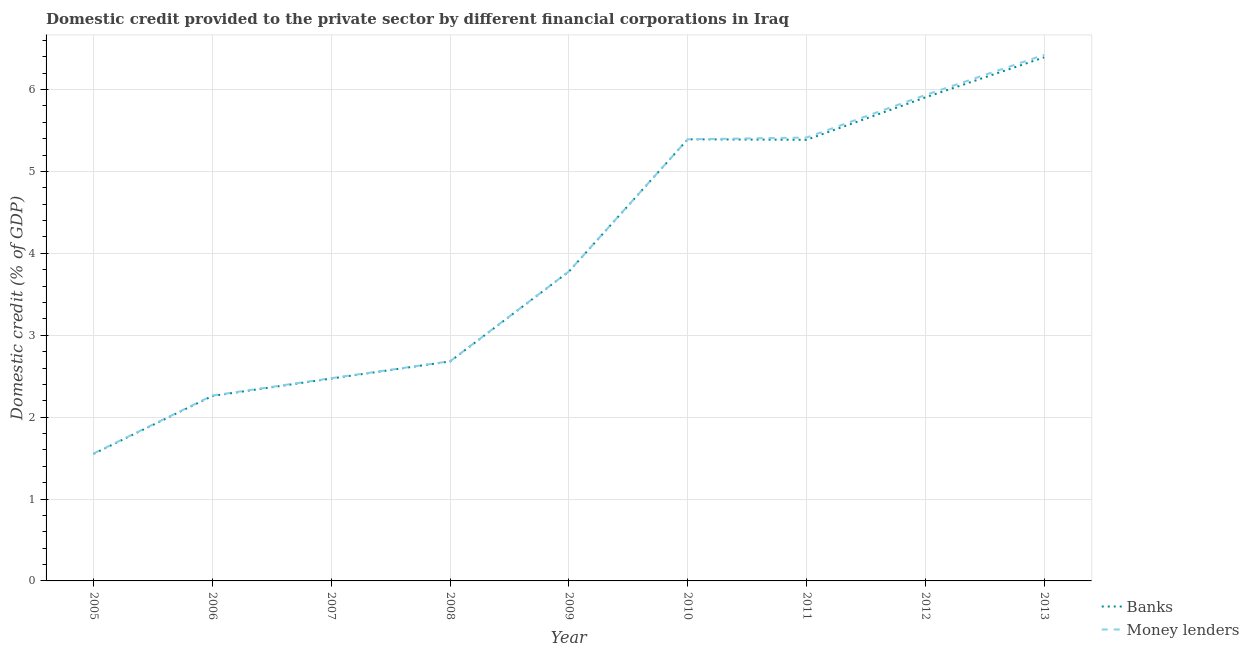Is the number of lines equal to the number of legend labels?
Ensure brevity in your answer.  Yes. What is the domestic credit provided by banks in 2012?
Offer a very short reply. 5.9. Across all years, what is the maximum domestic credit provided by banks?
Provide a short and direct response. 6.39. Across all years, what is the minimum domestic credit provided by money lenders?
Your response must be concise. 1.56. In which year was the domestic credit provided by money lenders minimum?
Ensure brevity in your answer.  2005. What is the total domestic credit provided by money lenders in the graph?
Provide a succinct answer. 35.92. What is the difference between the domestic credit provided by banks in 2006 and that in 2008?
Your answer should be very brief. -0.42. What is the difference between the domestic credit provided by money lenders in 2012 and the domestic credit provided by banks in 2013?
Keep it short and to the point. -0.46. What is the average domestic credit provided by banks per year?
Give a very brief answer. 3.98. In the year 2008, what is the difference between the domestic credit provided by money lenders and domestic credit provided by banks?
Give a very brief answer. 0. In how many years, is the domestic credit provided by banks greater than 5.8 %?
Offer a very short reply. 2. What is the ratio of the domestic credit provided by banks in 2005 to that in 2010?
Offer a terse response. 0.29. Is the difference between the domestic credit provided by money lenders in 2009 and 2010 greater than the difference between the domestic credit provided by banks in 2009 and 2010?
Offer a terse response. Yes. What is the difference between the highest and the second highest domestic credit provided by money lenders?
Your answer should be very brief. 0.49. What is the difference between the highest and the lowest domestic credit provided by banks?
Give a very brief answer. 4.84. Is the domestic credit provided by money lenders strictly less than the domestic credit provided by banks over the years?
Give a very brief answer. No. How many lines are there?
Offer a terse response. 2. How many years are there in the graph?
Your answer should be compact. 9. Are the values on the major ticks of Y-axis written in scientific E-notation?
Give a very brief answer. No. Does the graph contain any zero values?
Your response must be concise. No. Where does the legend appear in the graph?
Your answer should be very brief. Bottom right. How are the legend labels stacked?
Provide a short and direct response. Vertical. What is the title of the graph?
Provide a succinct answer. Domestic credit provided to the private sector by different financial corporations in Iraq. Does "Start a business" appear as one of the legend labels in the graph?
Provide a short and direct response. No. What is the label or title of the Y-axis?
Give a very brief answer. Domestic credit (% of GDP). What is the Domestic credit (% of GDP) of Banks in 2005?
Provide a short and direct response. 1.55. What is the Domestic credit (% of GDP) in Money lenders in 2005?
Give a very brief answer. 1.56. What is the Domestic credit (% of GDP) of Banks in 2006?
Offer a very short reply. 2.26. What is the Domestic credit (% of GDP) of Money lenders in 2006?
Provide a short and direct response. 2.26. What is the Domestic credit (% of GDP) in Banks in 2007?
Your response must be concise. 2.47. What is the Domestic credit (% of GDP) in Money lenders in 2007?
Your answer should be very brief. 2.48. What is the Domestic credit (% of GDP) in Banks in 2008?
Your response must be concise. 2.68. What is the Domestic credit (% of GDP) in Money lenders in 2008?
Provide a short and direct response. 2.68. What is the Domestic credit (% of GDP) in Banks in 2009?
Your answer should be compact. 3.78. What is the Domestic credit (% of GDP) of Money lenders in 2009?
Your answer should be compact. 3.78. What is the Domestic credit (% of GDP) in Banks in 2010?
Keep it short and to the point. 5.39. What is the Domestic credit (% of GDP) in Money lenders in 2010?
Give a very brief answer. 5.39. What is the Domestic credit (% of GDP) in Banks in 2011?
Your answer should be compact. 5.39. What is the Domestic credit (% of GDP) in Money lenders in 2011?
Ensure brevity in your answer.  5.41. What is the Domestic credit (% of GDP) in Banks in 2012?
Give a very brief answer. 5.9. What is the Domestic credit (% of GDP) of Money lenders in 2012?
Offer a very short reply. 5.93. What is the Domestic credit (% of GDP) of Banks in 2013?
Make the answer very short. 6.39. What is the Domestic credit (% of GDP) in Money lenders in 2013?
Your answer should be very brief. 6.42. Across all years, what is the maximum Domestic credit (% of GDP) of Banks?
Provide a succinct answer. 6.39. Across all years, what is the maximum Domestic credit (% of GDP) in Money lenders?
Give a very brief answer. 6.42. Across all years, what is the minimum Domestic credit (% of GDP) in Banks?
Provide a succinct answer. 1.55. Across all years, what is the minimum Domestic credit (% of GDP) of Money lenders?
Keep it short and to the point. 1.56. What is the total Domestic credit (% of GDP) in Banks in the graph?
Make the answer very short. 35.82. What is the total Domestic credit (% of GDP) of Money lenders in the graph?
Make the answer very short. 35.92. What is the difference between the Domestic credit (% of GDP) of Banks in 2005 and that in 2006?
Offer a very short reply. -0.71. What is the difference between the Domestic credit (% of GDP) of Money lenders in 2005 and that in 2006?
Give a very brief answer. -0.71. What is the difference between the Domestic credit (% of GDP) in Banks in 2005 and that in 2007?
Offer a terse response. -0.92. What is the difference between the Domestic credit (% of GDP) in Money lenders in 2005 and that in 2007?
Your answer should be very brief. -0.92. What is the difference between the Domestic credit (% of GDP) of Banks in 2005 and that in 2008?
Ensure brevity in your answer.  -1.13. What is the difference between the Domestic credit (% of GDP) of Money lenders in 2005 and that in 2008?
Your response must be concise. -1.13. What is the difference between the Domestic credit (% of GDP) in Banks in 2005 and that in 2009?
Offer a very short reply. -2.23. What is the difference between the Domestic credit (% of GDP) of Money lenders in 2005 and that in 2009?
Keep it short and to the point. -2.22. What is the difference between the Domestic credit (% of GDP) of Banks in 2005 and that in 2010?
Make the answer very short. -3.84. What is the difference between the Domestic credit (% of GDP) of Money lenders in 2005 and that in 2010?
Keep it short and to the point. -3.84. What is the difference between the Domestic credit (% of GDP) of Banks in 2005 and that in 2011?
Give a very brief answer. -3.84. What is the difference between the Domestic credit (% of GDP) of Money lenders in 2005 and that in 2011?
Your answer should be compact. -3.86. What is the difference between the Domestic credit (% of GDP) of Banks in 2005 and that in 2012?
Make the answer very short. -4.35. What is the difference between the Domestic credit (% of GDP) of Money lenders in 2005 and that in 2012?
Keep it short and to the point. -4.38. What is the difference between the Domestic credit (% of GDP) in Banks in 2005 and that in 2013?
Your answer should be very brief. -4.84. What is the difference between the Domestic credit (% of GDP) of Money lenders in 2005 and that in 2013?
Provide a succinct answer. -4.87. What is the difference between the Domestic credit (% of GDP) of Banks in 2006 and that in 2007?
Your response must be concise. -0.21. What is the difference between the Domestic credit (% of GDP) in Money lenders in 2006 and that in 2007?
Your answer should be compact. -0.21. What is the difference between the Domestic credit (% of GDP) of Banks in 2006 and that in 2008?
Offer a terse response. -0.42. What is the difference between the Domestic credit (% of GDP) of Money lenders in 2006 and that in 2008?
Give a very brief answer. -0.42. What is the difference between the Domestic credit (% of GDP) of Banks in 2006 and that in 2009?
Give a very brief answer. -1.52. What is the difference between the Domestic credit (% of GDP) in Money lenders in 2006 and that in 2009?
Provide a succinct answer. -1.51. What is the difference between the Domestic credit (% of GDP) of Banks in 2006 and that in 2010?
Your answer should be very brief. -3.13. What is the difference between the Domestic credit (% of GDP) of Money lenders in 2006 and that in 2010?
Ensure brevity in your answer.  -3.13. What is the difference between the Domestic credit (% of GDP) in Banks in 2006 and that in 2011?
Offer a very short reply. -3.13. What is the difference between the Domestic credit (% of GDP) of Money lenders in 2006 and that in 2011?
Offer a very short reply. -3.15. What is the difference between the Domestic credit (% of GDP) of Banks in 2006 and that in 2012?
Provide a succinct answer. -3.65. What is the difference between the Domestic credit (% of GDP) of Money lenders in 2006 and that in 2012?
Give a very brief answer. -3.67. What is the difference between the Domestic credit (% of GDP) of Banks in 2006 and that in 2013?
Give a very brief answer. -4.13. What is the difference between the Domestic credit (% of GDP) in Money lenders in 2006 and that in 2013?
Offer a very short reply. -4.16. What is the difference between the Domestic credit (% of GDP) in Banks in 2007 and that in 2008?
Your answer should be very brief. -0.21. What is the difference between the Domestic credit (% of GDP) of Money lenders in 2007 and that in 2008?
Keep it short and to the point. -0.21. What is the difference between the Domestic credit (% of GDP) in Banks in 2007 and that in 2009?
Give a very brief answer. -1.31. What is the difference between the Domestic credit (% of GDP) in Money lenders in 2007 and that in 2009?
Keep it short and to the point. -1.3. What is the difference between the Domestic credit (% of GDP) in Banks in 2007 and that in 2010?
Offer a very short reply. -2.92. What is the difference between the Domestic credit (% of GDP) in Money lenders in 2007 and that in 2010?
Your answer should be very brief. -2.92. What is the difference between the Domestic credit (% of GDP) in Banks in 2007 and that in 2011?
Give a very brief answer. -2.92. What is the difference between the Domestic credit (% of GDP) of Money lenders in 2007 and that in 2011?
Ensure brevity in your answer.  -2.94. What is the difference between the Domestic credit (% of GDP) of Banks in 2007 and that in 2012?
Offer a terse response. -3.43. What is the difference between the Domestic credit (% of GDP) of Money lenders in 2007 and that in 2012?
Your response must be concise. -3.46. What is the difference between the Domestic credit (% of GDP) of Banks in 2007 and that in 2013?
Provide a short and direct response. -3.92. What is the difference between the Domestic credit (% of GDP) of Money lenders in 2007 and that in 2013?
Keep it short and to the point. -3.95. What is the difference between the Domestic credit (% of GDP) in Banks in 2008 and that in 2009?
Offer a terse response. -1.1. What is the difference between the Domestic credit (% of GDP) in Money lenders in 2008 and that in 2009?
Ensure brevity in your answer.  -1.1. What is the difference between the Domestic credit (% of GDP) in Banks in 2008 and that in 2010?
Give a very brief answer. -2.71. What is the difference between the Domestic credit (% of GDP) in Money lenders in 2008 and that in 2010?
Provide a succinct answer. -2.71. What is the difference between the Domestic credit (% of GDP) of Banks in 2008 and that in 2011?
Provide a succinct answer. -2.71. What is the difference between the Domestic credit (% of GDP) of Money lenders in 2008 and that in 2011?
Keep it short and to the point. -2.73. What is the difference between the Domestic credit (% of GDP) in Banks in 2008 and that in 2012?
Provide a succinct answer. -3.22. What is the difference between the Domestic credit (% of GDP) in Money lenders in 2008 and that in 2012?
Ensure brevity in your answer.  -3.25. What is the difference between the Domestic credit (% of GDP) in Banks in 2008 and that in 2013?
Give a very brief answer. -3.71. What is the difference between the Domestic credit (% of GDP) in Money lenders in 2008 and that in 2013?
Keep it short and to the point. -3.74. What is the difference between the Domestic credit (% of GDP) in Banks in 2009 and that in 2010?
Your answer should be very brief. -1.61. What is the difference between the Domestic credit (% of GDP) in Money lenders in 2009 and that in 2010?
Your response must be concise. -1.61. What is the difference between the Domestic credit (% of GDP) of Banks in 2009 and that in 2011?
Provide a succinct answer. -1.61. What is the difference between the Domestic credit (% of GDP) in Money lenders in 2009 and that in 2011?
Offer a terse response. -1.64. What is the difference between the Domestic credit (% of GDP) in Banks in 2009 and that in 2012?
Offer a terse response. -2.13. What is the difference between the Domestic credit (% of GDP) of Money lenders in 2009 and that in 2012?
Your answer should be compact. -2.15. What is the difference between the Domestic credit (% of GDP) in Banks in 2009 and that in 2013?
Give a very brief answer. -2.62. What is the difference between the Domestic credit (% of GDP) of Money lenders in 2009 and that in 2013?
Make the answer very short. -2.65. What is the difference between the Domestic credit (% of GDP) in Banks in 2010 and that in 2011?
Offer a terse response. 0.01. What is the difference between the Domestic credit (% of GDP) of Money lenders in 2010 and that in 2011?
Offer a terse response. -0.02. What is the difference between the Domestic credit (% of GDP) in Banks in 2010 and that in 2012?
Give a very brief answer. -0.51. What is the difference between the Domestic credit (% of GDP) of Money lenders in 2010 and that in 2012?
Your response must be concise. -0.54. What is the difference between the Domestic credit (% of GDP) of Banks in 2010 and that in 2013?
Provide a short and direct response. -1. What is the difference between the Domestic credit (% of GDP) in Money lenders in 2010 and that in 2013?
Offer a terse response. -1.03. What is the difference between the Domestic credit (% of GDP) in Banks in 2011 and that in 2012?
Provide a succinct answer. -0.52. What is the difference between the Domestic credit (% of GDP) in Money lenders in 2011 and that in 2012?
Your answer should be very brief. -0.52. What is the difference between the Domestic credit (% of GDP) in Banks in 2011 and that in 2013?
Give a very brief answer. -1.01. What is the difference between the Domestic credit (% of GDP) in Money lenders in 2011 and that in 2013?
Provide a succinct answer. -1.01. What is the difference between the Domestic credit (% of GDP) in Banks in 2012 and that in 2013?
Offer a terse response. -0.49. What is the difference between the Domestic credit (% of GDP) of Money lenders in 2012 and that in 2013?
Make the answer very short. -0.49. What is the difference between the Domestic credit (% of GDP) in Banks in 2005 and the Domestic credit (% of GDP) in Money lenders in 2006?
Provide a succinct answer. -0.71. What is the difference between the Domestic credit (% of GDP) of Banks in 2005 and the Domestic credit (% of GDP) of Money lenders in 2007?
Provide a succinct answer. -0.92. What is the difference between the Domestic credit (% of GDP) of Banks in 2005 and the Domestic credit (% of GDP) of Money lenders in 2008?
Offer a terse response. -1.13. What is the difference between the Domestic credit (% of GDP) in Banks in 2005 and the Domestic credit (% of GDP) in Money lenders in 2009?
Make the answer very short. -2.23. What is the difference between the Domestic credit (% of GDP) of Banks in 2005 and the Domestic credit (% of GDP) of Money lenders in 2010?
Your response must be concise. -3.84. What is the difference between the Domestic credit (% of GDP) of Banks in 2005 and the Domestic credit (% of GDP) of Money lenders in 2011?
Keep it short and to the point. -3.86. What is the difference between the Domestic credit (% of GDP) in Banks in 2005 and the Domestic credit (% of GDP) in Money lenders in 2012?
Ensure brevity in your answer.  -4.38. What is the difference between the Domestic credit (% of GDP) in Banks in 2005 and the Domestic credit (% of GDP) in Money lenders in 2013?
Your response must be concise. -4.87. What is the difference between the Domestic credit (% of GDP) in Banks in 2006 and the Domestic credit (% of GDP) in Money lenders in 2007?
Provide a short and direct response. -0.22. What is the difference between the Domestic credit (% of GDP) of Banks in 2006 and the Domestic credit (% of GDP) of Money lenders in 2008?
Make the answer very short. -0.42. What is the difference between the Domestic credit (% of GDP) of Banks in 2006 and the Domestic credit (% of GDP) of Money lenders in 2009?
Offer a very short reply. -1.52. What is the difference between the Domestic credit (% of GDP) in Banks in 2006 and the Domestic credit (% of GDP) in Money lenders in 2010?
Give a very brief answer. -3.13. What is the difference between the Domestic credit (% of GDP) of Banks in 2006 and the Domestic credit (% of GDP) of Money lenders in 2011?
Your answer should be compact. -3.16. What is the difference between the Domestic credit (% of GDP) in Banks in 2006 and the Domestic credit (% of GDP) in Money lenders in 2012?
Make the answer very short. -3.67. What is the difference between the Domestic credit (% of GDP) in Banks in 2006 and the Domestic credit (% of GDP) in Money lenders in 2013?
Give a very brief answer. -4.17. What is the difference between the Domestic credit (% of GDP) of Banks in 2007 and the Domestic credit (% of GDP) of Money lenders in 2008?
Your answer should be compact. -0.21. What is the difference between the Domestic credit (% of GDP) in Banks in 2007 and the Domestic credit (% of GDP) in Money lenders in 2009?
Give a very brief answer. -1.31. What is the difference between the Domestic credit (% of GDP) in Banks in 2007 and the Domestic credit (% of GDP) in Money lenders in 2010?
Give a very brief answer. -2.92. What is the difference between the Domestic credit (% of GDP) of Banks in 2007 and the Domestic credit (% of GDP) of Money lenders in 2011?
Ensure brevity in your answer.  -2.94. What is the difference between the Domestic credit (% of GDP) of Banks in 2007 and the Domestic credit (% of GDP) of Money lenders in 2012?
Your response must be concise. -3.46. What is the difference between the Domestic credit (% of GDP) of Banks in 2007 and the Domestic credit (% of GDP) of Money lenders in 2013?
Give a very brief answer. -3.95. What is the difference between the Domestic credit (% of GDP) in Banks in 2008 and the Domestic credit (% of GDP) in Money lenders in 2009?
Ensure brevity in your answer.  -1.1. What is the difference between the Domestic credit (% of GDP) in Banks in 2008 and the Domestic credit (% of GDP) in Money lenders in 2010?
Provide a short and direct response. -2.71. What is the difference between the Domestic credit (% of GDP) of Banks in 2008 and the Domestic credit (% of GDP) of Money lenders in 2011?
Your answer should be compact. -2.73. What is the difference between the Domestic credit (% of GDP) of Banks in 2008 and the Domestic credit (% of GDP) of Money lenders in 2012?
Your answer should be very brief. -3.25. What is the difference between the Domestic credit (% of GDP) of Banks in 2008 and the Domestic credit (% of GDP) of Money lenders in 2013?
Keep it short and to the point. -3.74. What is the difference between the Domestic credit (% of GDP) in Banks in 2009 and the Domestic credit (% of GDP) in Money lenders in 2010?
Offer a terse response. -1.62. What is the difference between the Domestic credit (% of GDP) of Banks in 2009 and the Domestic credit (% of GDP) of Money lenders in 2011?
Make the answer very short. -1.64. What is the difference between the Domestic credit (% of GDP) of Banks in 2009 and the Domestic credit (% of GDP) of Money lenders in 2012?
Make the answer very short. -2.16. What is the difference between the Domestic credit (% of GDP) in Banks in 2009 and the Domestic credit (% of GDP) in Money lenders in 2013?
Give a very brief answer. -2.65. What is the difference between the Domestic credit (% of GDP) of Banks in 2010 and the Domestic credit (% of GDP) of Money lenders in 2011?
Provide a succinct answer. -0.02. What is the difference between the Domestic credit (% of GDP) of Banks in 2010 and the Domestic credit (% of GDP) of Money lenders in 2012?
Your response must be concise. -0.54. What is the difference between the Domestic credit (% of GDP) in Banks in 2010 and the Domestic credit (% of GDP) in Money lenders in 2013?
Provide a short and direct response. -1.03. What is the difference between the Domestic credit (% of GDP) in Banks in 2011 and the Domestic credit (% of GDP) in Money lenders in 2012?
Make the answer very short. -0.55. What is the difference between the Domestic credit (% of GDP) in Banks in 2011 and the Domestic credit (% of GDP) in Money lenders in 2013?
Ensure brevity in your answer.  -1.04. What is the difference between the Domestic credit (% of GDP) in Banks in 2012 and the Domestic credit (% of GDP) in Money lenders in 2013?
Your answer should be compact. -0.52. What is the average Domestic credit (% of GDP) of Banks per year?
Ensure brevity in your answer.  3.98. What is the average Domestic credit (% of GDP) of Money lenders per year?
Give a very brief answer. 3.99. In the year 2005, what is the difference between the Domestic credit (% of GDP) in Banks and Domestic credit (% of GDP) in Money lenders?
Keep it short and to the point. -0. In the year 2006, what is the difference between the Domestic credit (% of GDP) in Banks and Domestic credit (% of GDP) in Money lenders?
Provide a succinct answer. -0.01. In the year 2007, what is the difference between the Domestic credit (% of GDP) of Banks and Domestic credit (% of GDP) of Money lenders?
Your response must be concise. -0. In the year 2008, what is the difference between the Domestic credit (% of GDP) in Banks and Domestic credit (% of GDP) in Money lenders?
Your answer should be very brief. -0. In the year 2009, what is the difference between the Domestic credit (% of GDP) in Banks and Domestic credit (% of GDP) in Money lenders?
Give a very brief answer. -0. In the year 2010, what is the difference between the Domestic credit (% of GDP) of Banks and Domestic credit (% of GDP) of Money lenders?
Ensure brevity in your answer.  -0. In the year 2011, what is the difference between the Domestic credit (% of GDP) in Banks and Domestic credit (% of GDP) in Money lenders?
Provide a succinct answer. -0.03. In the year 2012, what is the difference between the Domestic credit (% of GDP) of Banks and Domestic credit (% of GDP) of Money lenders?
Ensure brevity in your answer.  -0.03. In the year 2013, what is the difference between the Domestic credit (% of GDP) in Banks and Domestic credit (% of GDP) in Money lenders?
Offer a very short reply. -0.03. What is the ratio of the Domestic credit (% of GDP) of Banks in 2005 to that in 2006?
Make the answer very short. 0.69. What is the ratio of the Domestic credit (% of GDP) of Money lenders in 2005 to that in 2006?
Make the answer very short. 0.69. What is the ratio of the Domestic credit (% of GDP) in Banks in 2005 to that in 2007?
Provide a short and direct response. 0.63. What is the ratio of the Domestic credit (% of GDP) in Money lenders in 2005 to that in 2007?
Give a very brief answer. 0.63. What is the ratio of the Domestic credit (% of GDP) of Banks in 2005 to that in 2008?
Make the answer very short. 0.58. What is the ratio of the Domestic credit (% of GDP) of Money lenders in 2005 to that in 2008?
Your answer should be compact. 0.58. What is the ratio of the Domestic credit (% of GDP) of Banks in 2005 to that in 2009?
Offer a very short reply. 0.41. What is the ratio of the Domestic credit (% of GDP) of Money lenders in 2005 to that in 2009?
Keep it short and to the point. 0.41. What is the ratio of the Domestic credit (% of GDP) in Banks in 2005 to that in 2010?
Ensure brevity in your answer.  0.29. What is the ratio of the Domestic credit (% of GDP) in Money lenders in 2005 to that in 2010?
Your answer should be very brief. 0.29. What is the ratio of the Domestic credit (% of GDP) in Banks in 2005 to that in 2011?
Your answer should be very brief. 0.29. What is the ratio of the Domestic credit (% of GDP) of Money lenders in 2005 to that in 2011?
Offer a terse response. 0.29. What is the ratio of the Domestic credit (% of GDP) in Banks in 2005 to that in 2012?
Keep it short and to the point. 0.26. What is the ratio of the Domestic credit (% of GDP) of Money lenders in 2005 to that in 2012?
Offer a terse response. 0.26. What is the ratio of the Domestic credit (% of GDP) of Banks in 2005 to that in 2013?
Give a very brief answer. 0.24. What is the ratio of the Domestic credit (% of GDP) in Money lenders in 2005 to that in 2013?
Your answer should be very brief. 0.24. What is the ratio of the Domestic credit (% of GDP) in Banks in 2006 to that in 2007?
Keep it short and to the point. 0.91. What is the ratio of the Domestic credit (% of GDP) of Money lenders in 2006 to that in 2007?
Provide a succinct answer. 0.91. What is the ratio of the Domestic credit (% of GDP) in Banks in 2006 to that in 2008?
Your answer should be very brief. 0.84. What is the ratio of the Domestic credit (% of GDP) in Money lenders in 2006 to that in 2008?
Provide a short and direct response. 0.84. What is the ratio of the Domestic credit (% of GDP) of Banks in 2006 to that in 2009?
Your answer should be very brief. 0.6. What is the ratio of the Domestic credit (% of GDP) of Money lenders in 2006 to that in 2009?
Give a very brief answer. 0.6. What is the ratio of the Domestic credit (% of GDP) of Banks in 2006 to that in 2010?
Ensure brevity in your answer.  0.42. What is the ratio of the Domestic credit (% of GDP) of Money lenders in 2006 to that in 2010?
Your answer should be very brief. 0.42. What is the ratio of the Domestic credit (% of GDP) in Banks in 2006 to that in 2011?
Offer a terse response. 0.42. What is the ratio of the Domestic credit (% of GDP) of Money lenders in 2006 to that in 2011?
Provide a short and direct response. 0.42. What is the ratio of the Domestic credit (% of GDP) of Banks in 2006 to that in 2012?
Offer a terse response. 0.38. What is the ratio of the Domestic credit (% of GDP) of Money lenders in 2006 to that in 2012?
Keep it short and to the point. 0.38. What is the ratio of the Domestic credit (% of GDP) of Banks in 2006 to that in 2013?
Provide a succinct answer. 0.35. What is the ratio of the Domestic credit (% of GDP) of Money lenders in 2006 to that in 2013?
Make the answer very short. 0.35. What is the ratio of the Domestic credit (% of GDP) in Banks in 2007 to that in 2008?
Keep it short and to the point. 0.92. What is the ratio of the Domestic credit (% of GDP) of Money lenders in 2007 to that in 2008?
Offer a very short reply. 0.92. What is the ratio of the Domestic credit (% of GDP) of Banks in 2007 to that in 2009?
Your response must be concise. 0.65. What is the ratio of the Domestic credit (% of GDP) in Money lenders in 2007 to that in 2009?
Ensure brevity in your answer.  0.66. What is the ratio of the Domestic credit (% of GDP) of Banks in 2007 to that in 2010?
Make the answer very short. 0.46. What is the ratio of the Domestic credit (% of GDP) in Money lenders in 2007 to that in 2010?
Offer a terse response. 0.46. What is the ratio of the Domestic credit (% of GDP) in Banks in 2007 to that in 2011?
Make the answer very short. 0.46. What is the ratio of the Domestic credit (% of GDP) of Money lenders in 2007 to that in 2011?
Offer a terse response. 0.46. What is the ratio of the Domestic credit (% of GDP) of Banks in 2007 to that in 2012?
Your answer should be compact. 0.42. What is the ratio of the Domestic credit (% of GDP) in Money lenders in 2007 to that in 2012?
Your answer should be very brief. 0.42. What is the ratio of the Domestic credit (% of GDP) of Banks in 2007 to that in 2013?
Offer a terse response. 0.39. What is the ratio of the Domestic credit (% of GDP) in Money lenders in 2007 to that in 2013?
Your answer should be compact. 0.39. What is the ratio of the Domestic credit (% of GDP) in Banks in 2008 to that in 2009?
Keep it short and to the point. 0.71. What is the ratio of the Domestic credit (% of GDP) in Money lenders in 2008 to that in 2009?
Keep it short and to the point. 0.71. What is the ratio of the Domestic credit (% of GDP) in Banks in 2008 to that in 2010?
Make the answer very short. 0.5. What is the ratio of the Domestic credit (% of GDP) of Money lenders in 2008 to that in 2010?
Give a very brief answer. 0.5. What is the ratio of the Domestic credit (% of GDP) in Banks in 2008 to that in 2011?
Ensure brevity in your answer.  0.5. What is the ratio of the Domestic credit (% of GDP) in Money lenders in 2008 to that in 2011?
Your response must be concise. 0.5. What is the ratio of the Domestic credit (% of GDP) in Banks in 2008 to that in 2012?
Your response must be concise. 0.45. What is the ratio of the Domestic credit (% of GDP) of Money lenders in 2008 to that in 2012?
Your response must be concise. 0.45. What is the ratio of the Domestic credit (% of GDP) of Banks in 2008 to that in 2013?
Your answer should be very brief. 0.42. What is the ratio of the Domestic credit (% of GDP) of Money lenders in 2008 to that in 2013?
Ensure brevity in your answer.  0.42. What is the ratio of the Domestic credit (% of GDP) in Banks in 2009 to that in 2010?
Your answer should be very brief. 0.7. What is the ratio of the Domestic credit (% of GDP) in Money lenders in 2009 to that in 2010?
Offer a very short reply. 0.7. What is the ratio of the Domestic credit (% of GDP) of Banks in 2009 to that in 2011?
Provide a succinct answer. 0.7. What is the ratio of the Domestic credit (% of GDP) in Money lenders in 2009 to that in 2011?
Your answer should be compact. 0.7. What is the ratio of the Domestic credit (% of GDP) in Banks in 2009 to that in 2012?
Make the answer very short. 0.64. What is the ratio of the Domestic credit (% of GDP) in Money lenders in 2009 to that in 2012?
Offer a very short reply. 0.64. What is the ratio of the Domestic credit (% of GDP) in Banks in 2009 to that in 2013?
Make the answer very short. 0.59. What is the ratio of the Domestic credit (% of GDP) of Money lenders in 2009 to that in 2013?
Offer a terse response. 0.59. What is the ratio of the Domestic credit (% of GDP) in Banks in 2010 to that in 2012?
Your answer should be very brief. 0.91. What is the ratio of the Domestic credit (% of GDP) in Money lenders in 2010 to that in 2012?
Give a very brief answer. 0.91. What is the ratio of the Domestic credit (% of GDP) of Banks in 2010 to that in 2013?
Keep it short and to the point. 0.84. What is the ratio of the Domestic credit (% of GDP) in Money lenders in 2010 to that in 2013?
Provide a short and direct response. 0.84. What is the ratio of the Domestic credit (% of GDP) of Banks in 2011 to that in 2012?
Keep it short and to the point. 0.91. What is the ratio of the Domestic credit (% of GDP) in Money lenders in 2011 to that in 2012?
Your answer should be very brief. 0.91. What is the ratio of the Domestic credit (% of GDP) of Banks in 2011 to that in 2013?
Your answer should be compact. 0.84. What is the ratio of the Domestic credit (% of GDP) of Money lenders in 2011 to that in 2013?
Offer a very short reply. 0.84. What is the ratio of the Domestic credit (% of GDP) in Banks in 2012 to that in 2013?
Your response must be concise. 0.92. What is the ratio of the Domestic credit (% of GDP) in Money lenders in 2012 to that in 2013?
Offer a very short reply. 0.92. What is the difference between the highest and the second highest Domestic credit (% of GDP) of Banks?
Ensure brevity in your answer.  0.49. What is the difference between the highest and the second highest Domestic credit (% of GDP) in Money lenders?
Provide a succinct answer. 0.49. What is the difference between the highest and the lowest Domestic credit (% of GDP) of Banks?
Your answer should be very brief. 4.84. What is the difference between the highest and the lowest Domestic credit (% of GDP) of Money lenders?
Give a very brief answer. 4.87. 